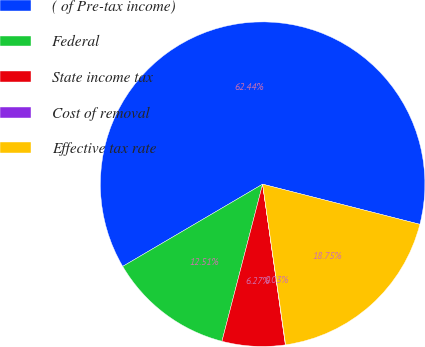Convert chart. <chart><loc_0><loc_0><loc_500><loc_500><pie_chart><fcel>( of Pre-tax income)<fcel>Federal<fcel>State income tax<fcel>Cost of removal<fcel>Effective tax rate<nl><fcel>62.43%<fcel>12.51%<fcel>6.27%<fcel>0.03%<fcel>18.75%<nl></chart> 